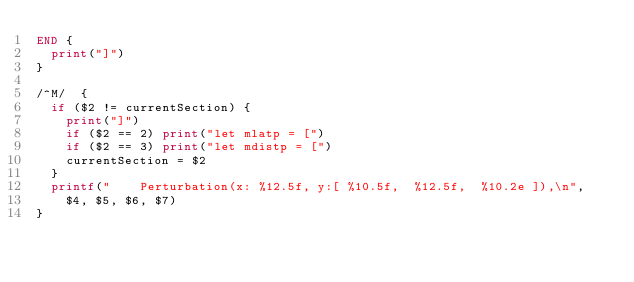Convert code to text. <code><loc_0><loc_0><loc_500><loc_500><_Awk_>END {
  print("]")
}

/^M/  {
  if ($2 != currentSection) {
    print("]")
    if ($2 == 2) print("let mlatp = [")
    if ($2 == 3) print("let mdistp = [")
    currentSection = $2
  }
  printf("    Perturbation(x: %12.5f, y:[ %10.5f,  %12.5f,  %10.2e ]),\n",
    $4, $5, $6, $7)
}
</code> 